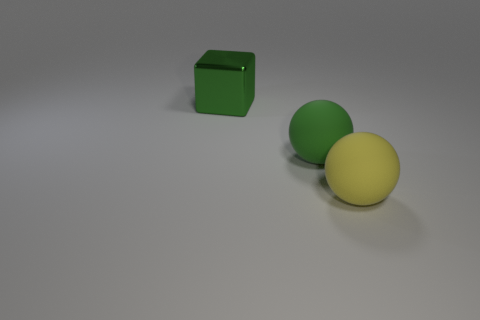Add 3 green metallic things. How many objects exist? 6 Subtract all blocks. How many objects are left? 2 Add 1 large green rubber spheres. How many large green rubber spheres exist? 2 Subtract 0 blue cubes. How many objects are left? 3 Subtract all gray metal balls. Subtract all large matte things. How many objects are left? 1 Add 2 big rubber spheres. How many big rubber spheres are left? 4 